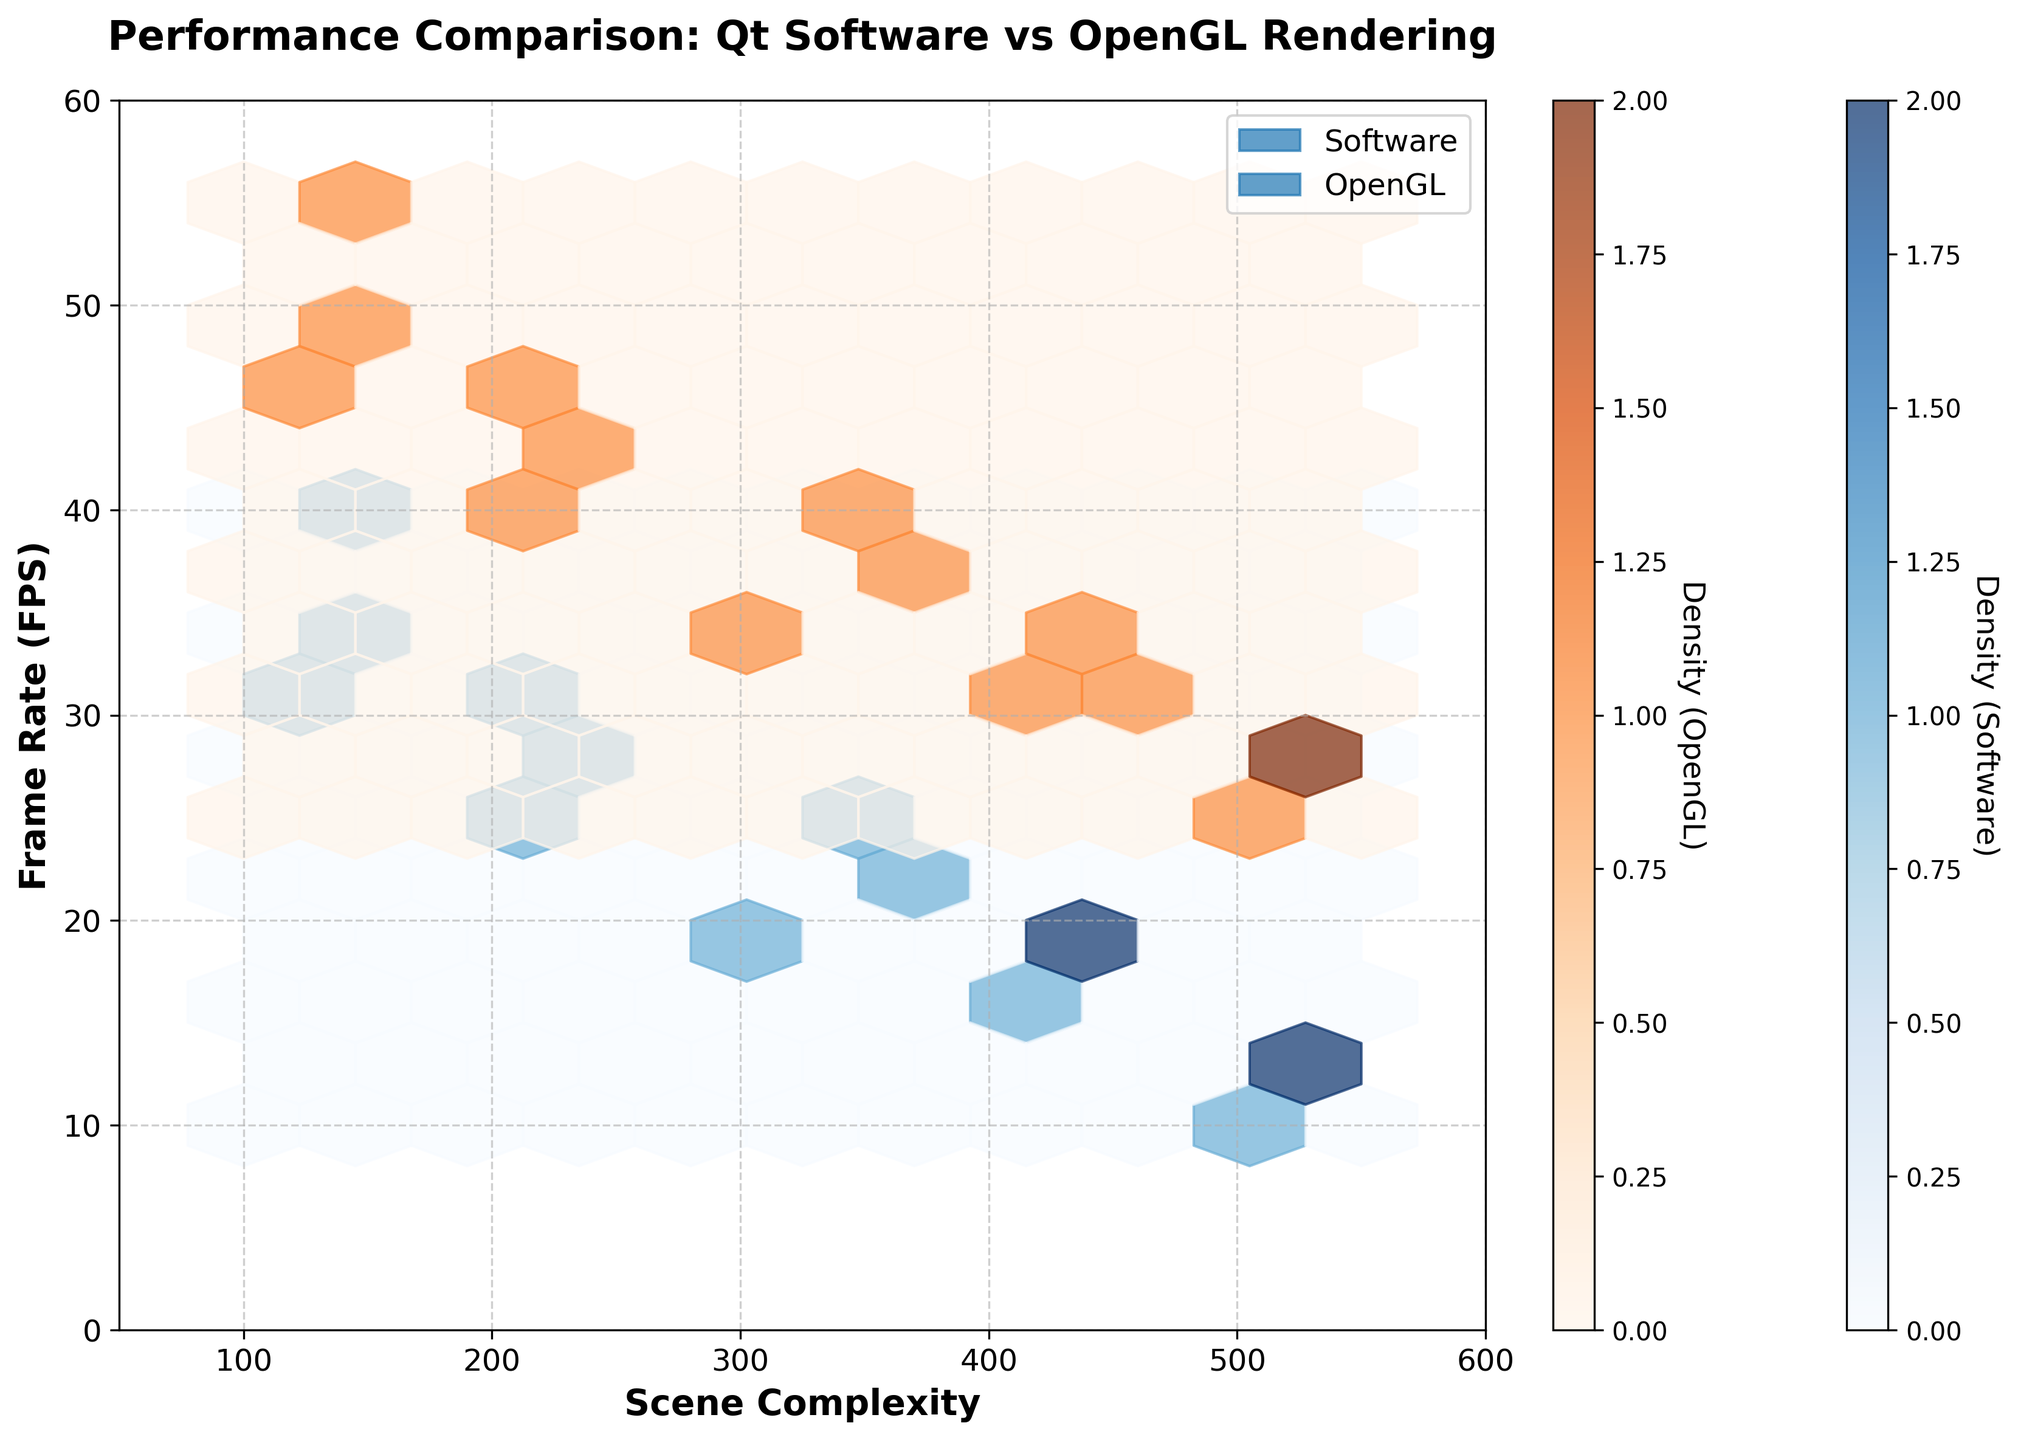what is the overall title of the plot? The title is displayed at the top of the plot and reads "Performance Comparison: Qt Software vs OpenGL Rendering".
Answer: Performance Comparison: Qt Software vs OpenGL Rendering what are the x and y axes labeled? The x-axis is labeled "Scene Complexity" and the y-axis is labeled "Frame Rate (FPS)".
Answer: Scene Complexity, Frame Rate (FPS) what are the colors representing in this plot? The plot uses two different colors to differentiate between the two rendering backends: blue for Software and orange for OpenGL.
Answer: blue for Software, orange for OpenGL what are the ranges of the x and y axes? The x-axis ranges from 50 to 600 and the y-axis ranges from 0 to 60, as indicated by the axis limits.
Answer: 50-600, 0-60 which rendering backend shows higher frame rates for lower scene complexity? By comparing the colors in the lower complexity range, we see that the OpenGL (orange) hexagons are generally higher on the y-axis than the Software (blue) hexagons, indicating higher frame rates for OpenGL.
Answer: OpenGL how does frame rate change with increasing scene complexity for software rendering? For Software, the blue hexagons are decreasing in height as the scene complexity increases along the x-axis, indicating that the frame rate decreases with increasing complexity.
Answer: decreases how do the densities of data points differ between Software and OpenGL rendering? This can be evaluated by observing the density color bars. Software uses a blue density scale from light to dark blue, and OpenGL uses orange. Generally, both scales show that there are fewer high-density areas, but exact densities can be inferred from the shades of the hexagons in the plot.
Answer: differ based on color intensity what is the underlying trend for OpenGL rendering as the scene complexity increases? For OpenGL, the orange hexagons start higher on the y-axis and decrease in height as scene complexity increases, indicating that frame rate also decreases with increasing complexity, but at a higher starting point compared to software.
Answer: decreases at higher rates how is the data distribution difference between Software and OpenGL rendering shown on the figure? The data distribution difference is shown through the relative positions and colors of the hexagons; blue representing Software is generally lower on the y-axis while orange representing OpenGL is higher, showing better performance for OpenGL across complexity levels.
Answer: hexagon positions and colors 